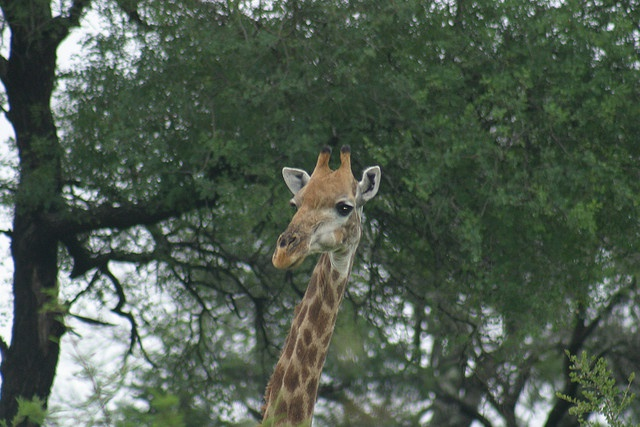Describe the objects in this image and their specific colors. I can see a giraffe in black and gray tones in this image. 